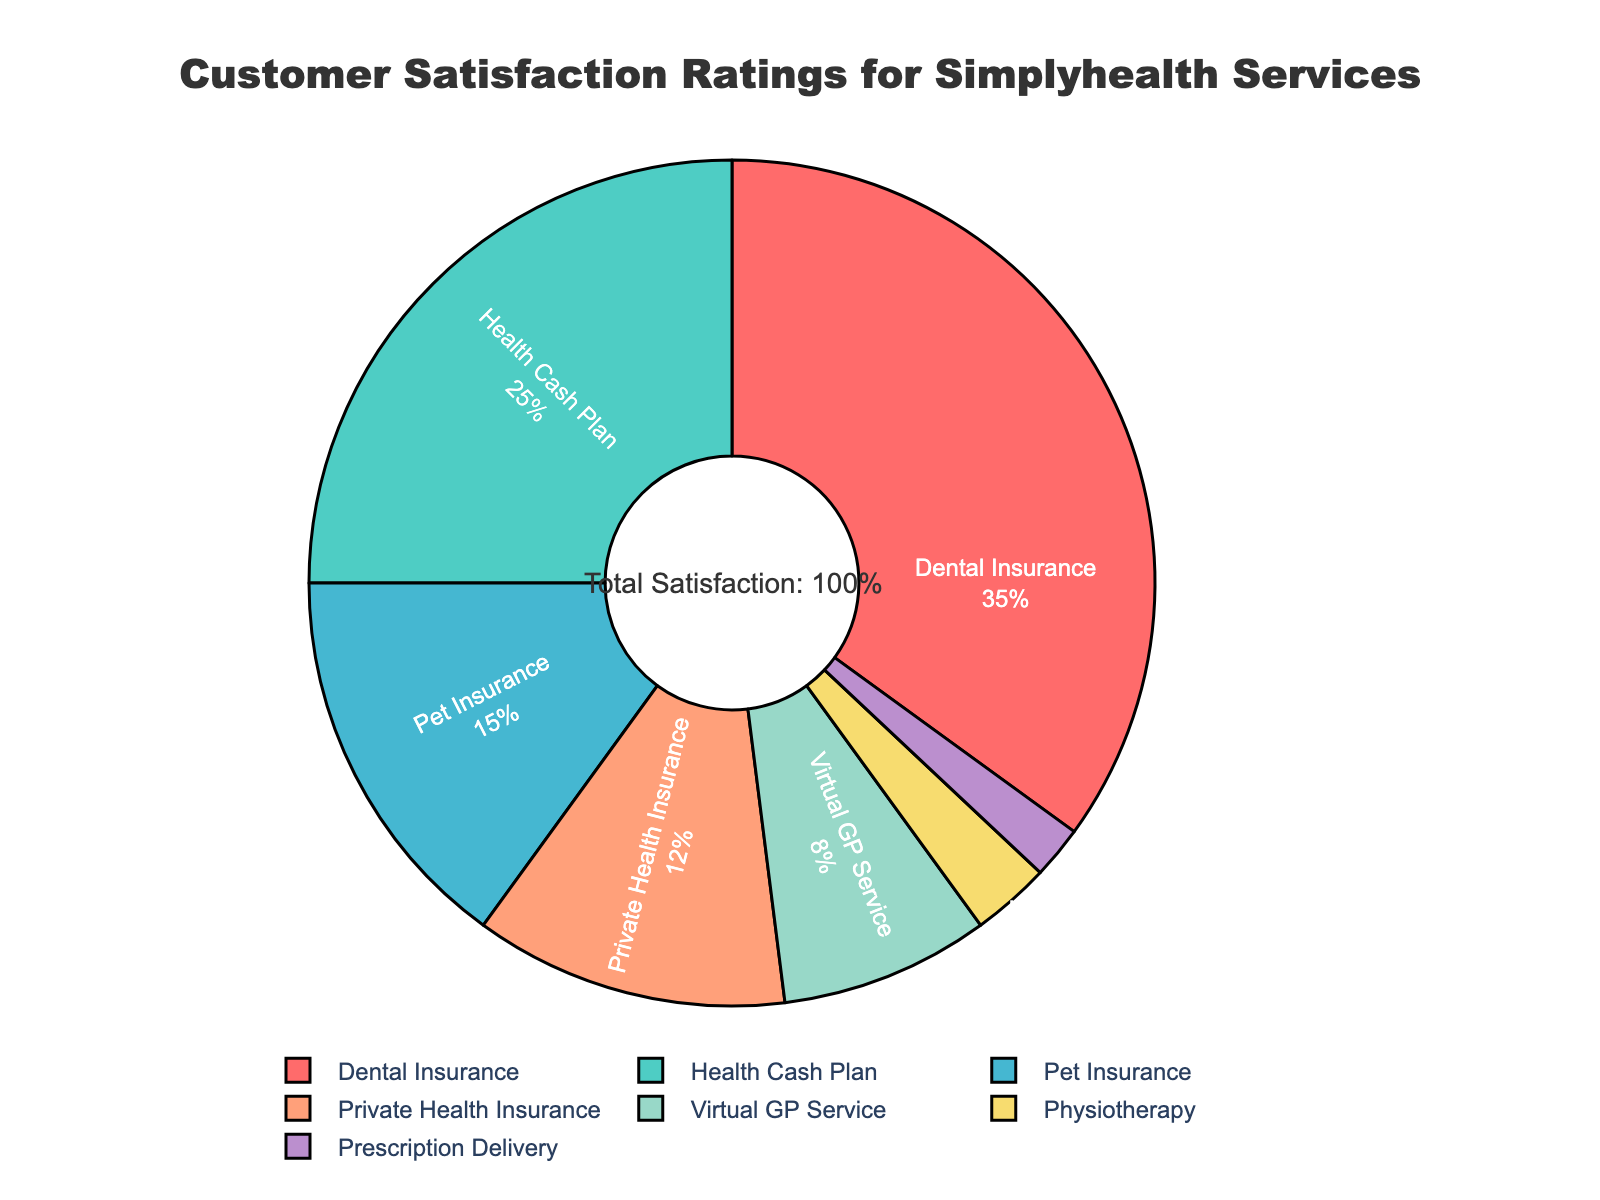Which Simplyhealth service has the highest customer satisfaction percentage? By looking at the labels and percentages on the pie chart, we can identify the service with the highest percentage.
Answer: Dental Insurance Which service has the lowest customer satisfaction percentage and how much is it? We can find the smallest slice of the pie chart and read the corresponding label and percentage.
Answer: Prescription Delivery, 2% What's the combined customer satisfaction percentage for Virtual GP Service and Physiotherapy? Add the percentages for Virtual GP Service (8%) and Physiotherapy (3%).
Answer: 11% Which service has a higher customer satisfaction percentage: Pet Insurance or Private Health Insurance? Compare the percentages for Pet Insurance (15%) and Private Health Insurance (12%).
Answer: Pet Insurance How much more is the customer satisfaction percentage for Health Cash Plan compared to Prescription Delivery? Subtract the percentage of Prescription Delivery (2%) from the percentage of Health Cash Plan (25%).
Answer: 23% What is the total customer satisfaction percentage for all insurance services combined (Dental, Pet, and Private Health Insurance)? Add the percentages for Dental Insurance (35%), Pet Insurance (15%), and Private Health Insurance (12%).
Answer: 62% Among the services with customer satisfaction percentages less than 10%, which service has the highest percentage? Identify services with percentages less than 10%, i.e., Virtual GP Service (8%), Physiotherapy (3%), and Prescription Delivery (2%), and then look for the highest percentage among them.
Answer: Virtual GP Service How does the customer satisfaction percentage for Dental Insurance compare with Health Cash Plan? Compare the percentages for Dental Insurance (35%) and Health Cash Plan (25%) by stating their difference.
Answer: 10% higher for Dental Insurance If Physiotherapy and Prescription Delivery satisfaction percentages were combined, would they surpass the Virtual GP Service percentage? Add the percentages for Physiotherapy (3%) and Prescription Delivery (2%) and compare the result (5%) with Virtual GP Service (8%).
Answer: No Which service has just over double the satisfaction percentage of Virtual GP Service? Identify the service whose percentage is slightly more than twice that of Virtual GP Service (8% × 2 = 16%), which is Pet Insurance at 15%.
Answer: Pet Insurance 